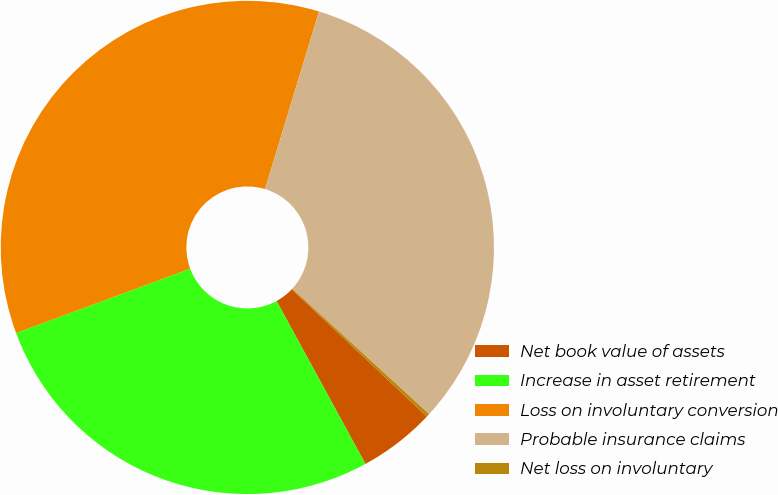Convert chart to OTSL. <chart><loc_0><loc_0><loc_500><loc_500><pie_chart><fcel>Net book value of assets<fcel>Increase in asset retirement<fcel>Loss on involuntary conversion<fcel>Probable insurance claims<fcel>Net loss on involuntary<nl><fcel>5.03%<fcel>27.3%<fcel>35.33%<fcel>32.12%<fcel>0.21%<nl></chart> 